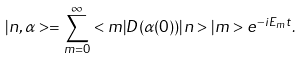Convert formula to latex. <formula><loc_0><loc_0><loc_500><loc_500>| n , \alpha > = \sum _ { m = 0 } ^ { \infty } < m | D ( \alpha ( 0 ) ) | n > | m > e ^ { - i E _ { m } t } .</formula> 